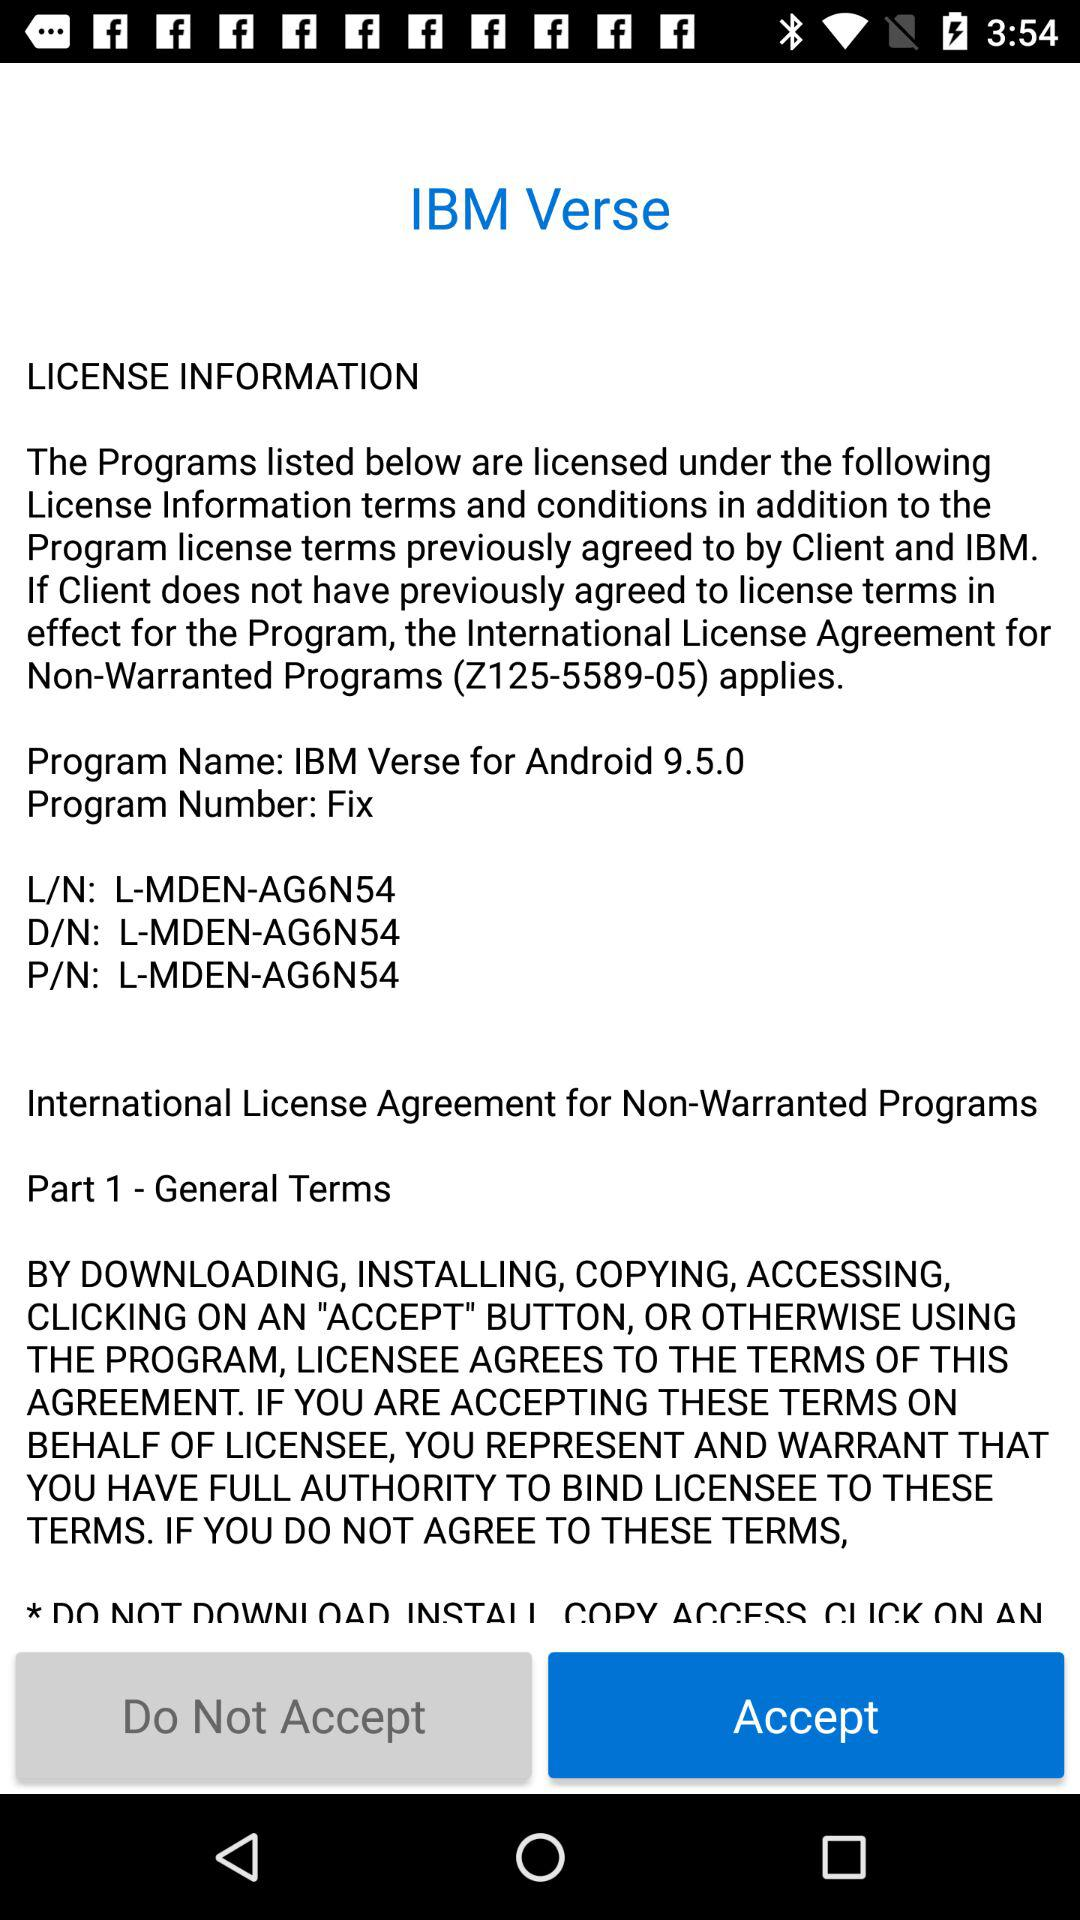What is the verse's program number? The verse's program number is "Fix". 